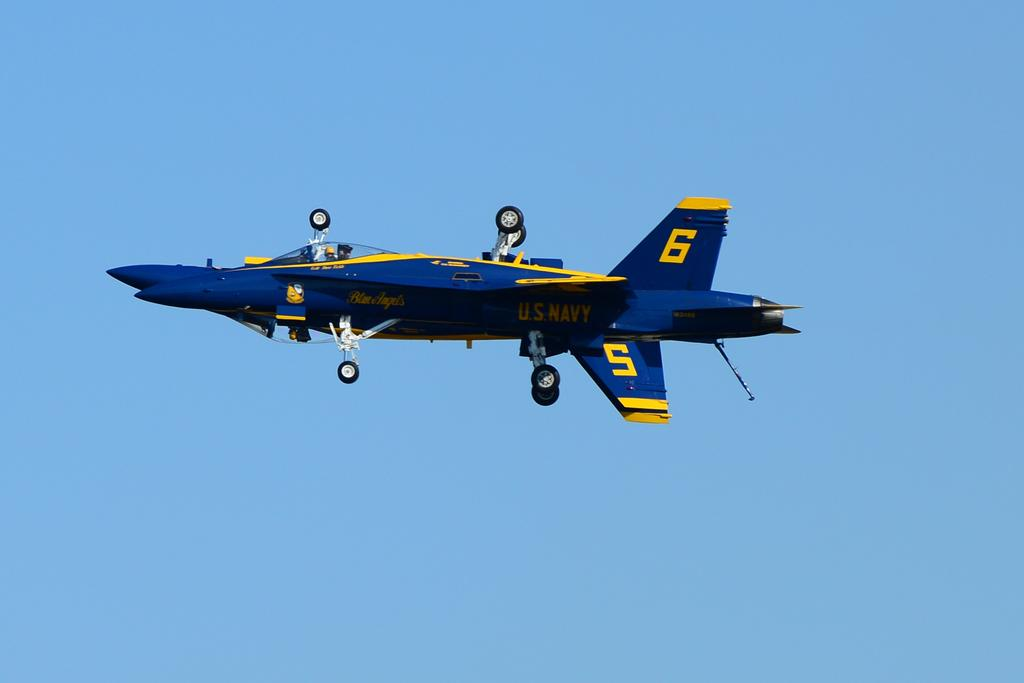<image>
Relay a brief, clear account of the picture shown. A blue and yellow aircraft in mid-flight is labeled with the numbers 5 and 6. 